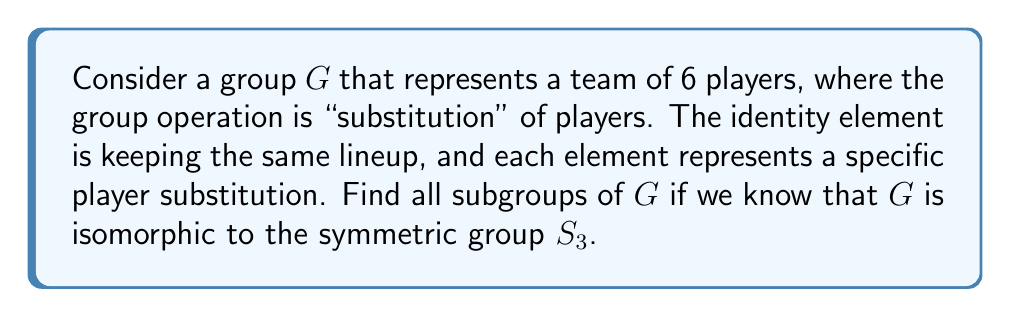Help me with this question. Let's approach this step-by-step:

1) First, recall that $S_3$ is the symmetric group of order 6. It contains all permutations of 3 elements.

2) The subgroups of $S_3$ are well-known, so we can use this knowledge to find the subgroups of $G$.

3) To find all subgroups, we need to consider all possible orders of subgroups. The order of a subgroup must divide the order of the group (Lagrange's Theorem). The divisors of 6 are 1, 2, 3, and 6.

4) Let's find subgroups for each possible order:

   a) Order 1: The trivial subgroup $\{e\}$ (no substitutions)
   
   b) Order 2: $S_3$ has three elements of order 2 (the transpositions). Each of these generates a subgroup of order 2. So there are three subgroups of order 2.
   
   c) Order 3: $S_3$ has two elements of order 3 (the 3-cycles). These two elements generate the same subgroup of order 3. So there is one subgroup of order 3.
   
   d) Order 6: The entire group $G$ itself.

5) In total, we have:
   - 1 subgroup of order 1
   - 3 subgroups of order 2
   - 1 subgroup of order 3
   - 1 subgroup of order 6 (the whole group)

This gives us a total of 6 subgroups.

In the context of the team, these subgroups represent different substitution patterns:
- The trivial subgroup: No substitutions
- Order 2 subgroups: Swapping two specific players
- Order 3 subgroup: Rotating three players
- The whole group: All possible substitutions
Answer: The group $G$ has 6 subgroups:
1) $\{e\}$ (order 1)
2) Three subgroups of order 2: $\{\{e,a\}, \{e,b\}, \{e,c\}\}$ where $a$, $b$, and $c$ are the elements of order 2
3) One subgroup of order 3: $\{e,r,r^2\}$ where $r$ is an element of order 3
4) $G$ itself (order 6) 